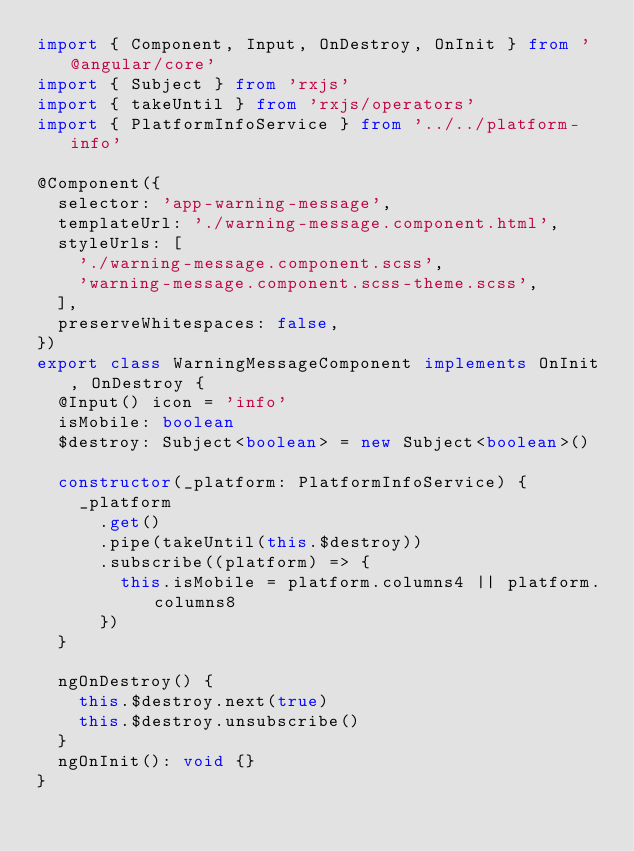<code> <loc_0><loc_0><loc_500><loc_500><_TypeScript_>import { Component, Input, OnDestroy, OnInit } from '@angular/core'
import { Subject } from 'rxjs'
import { takeUntil } from 'rxjs/operators'
import { PlatformInfoService } from '../../platform-info'

@Component({
  selector: 'app-warning-message',
  templateUrl: './warning-message.component.html',
  styleUrls: [
    './warning-message.component.scss',
    'warning-message.component.scss-theme.scss',
  ],
  preserveWhitespaces: false,
})
export class WarningMessageComponent implements OnInit, OnDestroy {
  @Input() icon = 'info'
  isMobile: boolean
  $destroy: Subject<boolean> = new Subject<boolean>()

  constructor(_platform: PlatformInfoService) {
    _platform
      .get()
      .pipe(takeUntil(this.$destroy))
      .subscribe((platform) => {
        this.isMobile = platform.columns4 || platform.columns8
      })
  }

  ngOnDestroy() {
    this.$destroy.next(true)
    this.$destroy.unsubscribe()
  }
  ngOnInit(): void {}
}
</code> 